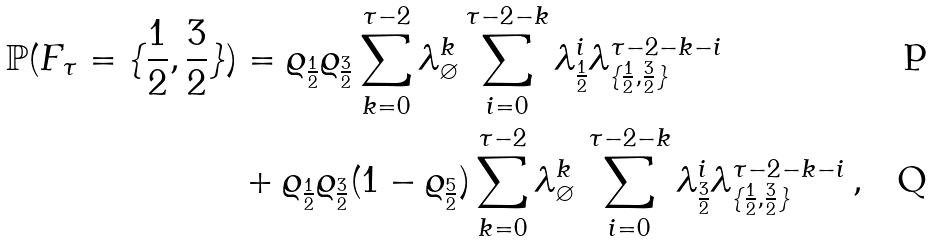<formula> <loc_0><loc_0><loc_500><loc_500>\mathbb { P } ( F _ { \tau } = \{ \frac { 1 } { 2 } , \frac { 3 } { 2 } \} ) & = \varrho _ { \frac { 1 } { 2 } } \varrho _ { \frac { 3 } { 2 } } \sum _ { k = 0 } ^ { \tau - 2 } \lambda ^ { k } _ { \varnothing } \sum _ { i = 0 } ^ { \tau - 2 - k } \lambda ^ { i } _ { \frac { 1 } { 2 } } \lambda ^ { \tau - 2 - k - i } _ { \{ \frac { 1 } { 2 } , \frac { 3 } { 2 } \} } \\ & + \varrho _ { \frac { 1 } { 2 } } \varrho _ { \frac { 3 } { 2 } } ( 1 - \varrho _ { \frac { 5 } { 2 } } ) \sum _ { k = 0 } ^ { \tau - 2 } \lambda ^ { k } _ { \varnothing } \, \sum _ { i = 0 } ^ { \tau - 2 - k } \lambda ^ { i } _ { \frac { 3 } { 2 } } \lambda ^ { \tau - 2 - k - i } _ { \{ \frac { 1 } { 2 } , \frac { 3 } { 2 } \} } \, ,</formula> 